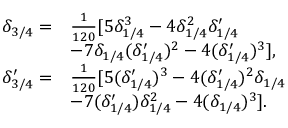Convert formula to latex. <formula><loc_0><loc_0><loc_500><loc_500>\begin{array} { r l } { \delta _ { 3 / 4 } = } & { \frac { 1 } { 1 2 0 } [ 5 \delta _ { 1 / 4 } ^ { 3 } - 4 \delta _ { 1 / 4 } ^ { 2 } \delta _ { 1 / 4 } ^ { \prime } } \\ & { - 7 \delta _ { 1 / 4 } ( \delta _ { 1 / 4 } ^ { \prime } ) ^ { 2 } - 4 ( \delta _ { 1 / 4 } ^ { \prime } ) ^ { 3 } ] , } \\ { \delta _ { 3 / 4 } ^ { \prime } = } & { \frac { 1 } { 1 2 0 } [ 5 ( \delta _ { 1 / 4 } ^ { \prime } ) ^ { 3 } - 4 ( \delta _ { 1 / 4 } ^ { \prime } ) ^ { 2 } \delta _ { 1 / 4 } } \\ & { - 7 ( \delta _ { 1 / 4 } ^ { \prime } ) \delta _ { 1 / 4 } ^ { 2 } - 4 ( \delta _ { 1 / 4 } ) ^ { 3 } ] . } \end{array}</formula> 